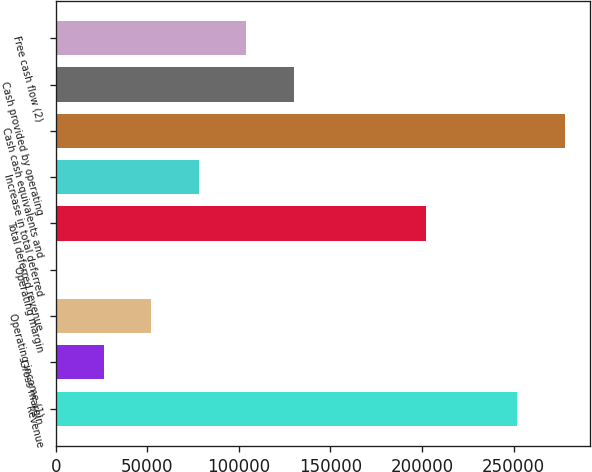<chart> <loc_0><loc_0><loc_500><loc_500><bar_chart><fcel>Revenue<fcel>Gross margin<fcel>Operating income (1)<fcel>Operating margin<fcel>Total deferred revenue<fcel>Increase in total deferred<fcel>Cash cash equivalents and<fcel>Cash provided by operating<fcel>Free cash flow (2)<nl><fcel>252115<fcel>26040.4<fcel>52070.8<fcel>10<fcel>201930<fcel>78101.2<fcel>278145<fcel>130162<fcel>104132<nl></chart> 